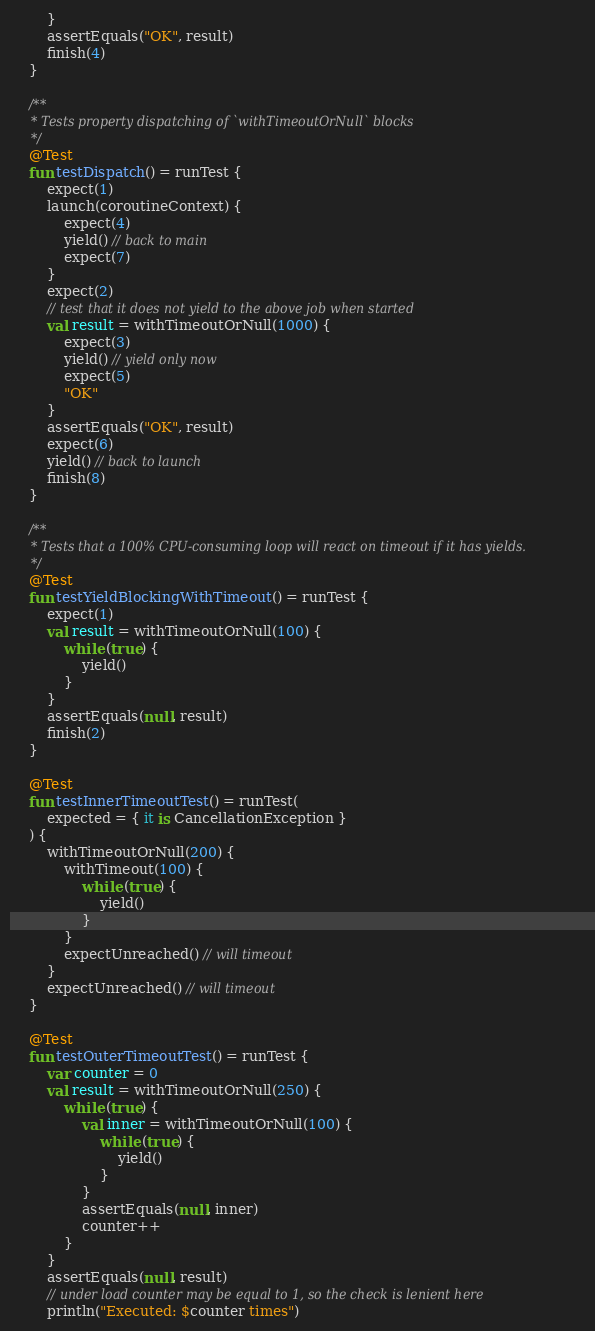Convert code to text. <code><loc_0><loc_0><loc_500><loc_500><_Kotlin_>        }
        assertEquals("OK", result)
        finish(4)
    }

    /**
     * Tests property dispatching of `withTimeoutOrNull` blocks
     */
    @Test
    fun testDispatch() = runTest {
        expect(1)
        launch(coroutineContext) {
            expect(4)
            yield() // back to main
            expect(7)
        }
        expect(2)
        // test that it does not yield to the above job when started
        val result = withTimeoutOrNull(1000) {
            expect(3)
            yield() // yield only now
            expect(5)
            "OK"
        }
        assertEquals("OK", result)
        expect(6)
        yield() // back to launch
        finish(8)
    }

    /**
     * Tests that a 100% CPU-consuming loop will react on timeout if it has yields.
     */
    @Test
    fun testYieldBlockingWithTimeout() = runTest {
        expect(1)
        val result = withTimeoutOrNull(100) {
            while (true) {
                yield()
            }
        }
        assertEquals(null, result)
        finish(2)
    }

    @Test
    fun testInnerTimeoutTest() = runTest(
        expected = { it is CancellationException }
    ) {
        withTimeoutOrNull(200) {
            withTimeout(100) {
                while (true) {
                    yield()
                }
            }
            expectUnreached() // will timeout
        }
        expectUnreached() // will timeout
    }

    @Test
    fun testOuterTimeoutTest() = runTest {
        var counter = 0
        val result = withTimeoutOrNull(250) {
            while (true) {
                val inner = withTimeoutOrNull(100) {
                    while (true) {
                        yield()
                    }
                }
                assertEquals(null, inner)
                counter++
            }
        }
        assertEquals(null, result)
        // under load counter may be equal to 1, so the check is lenient here
        println("Executed: $counter times")</code> 